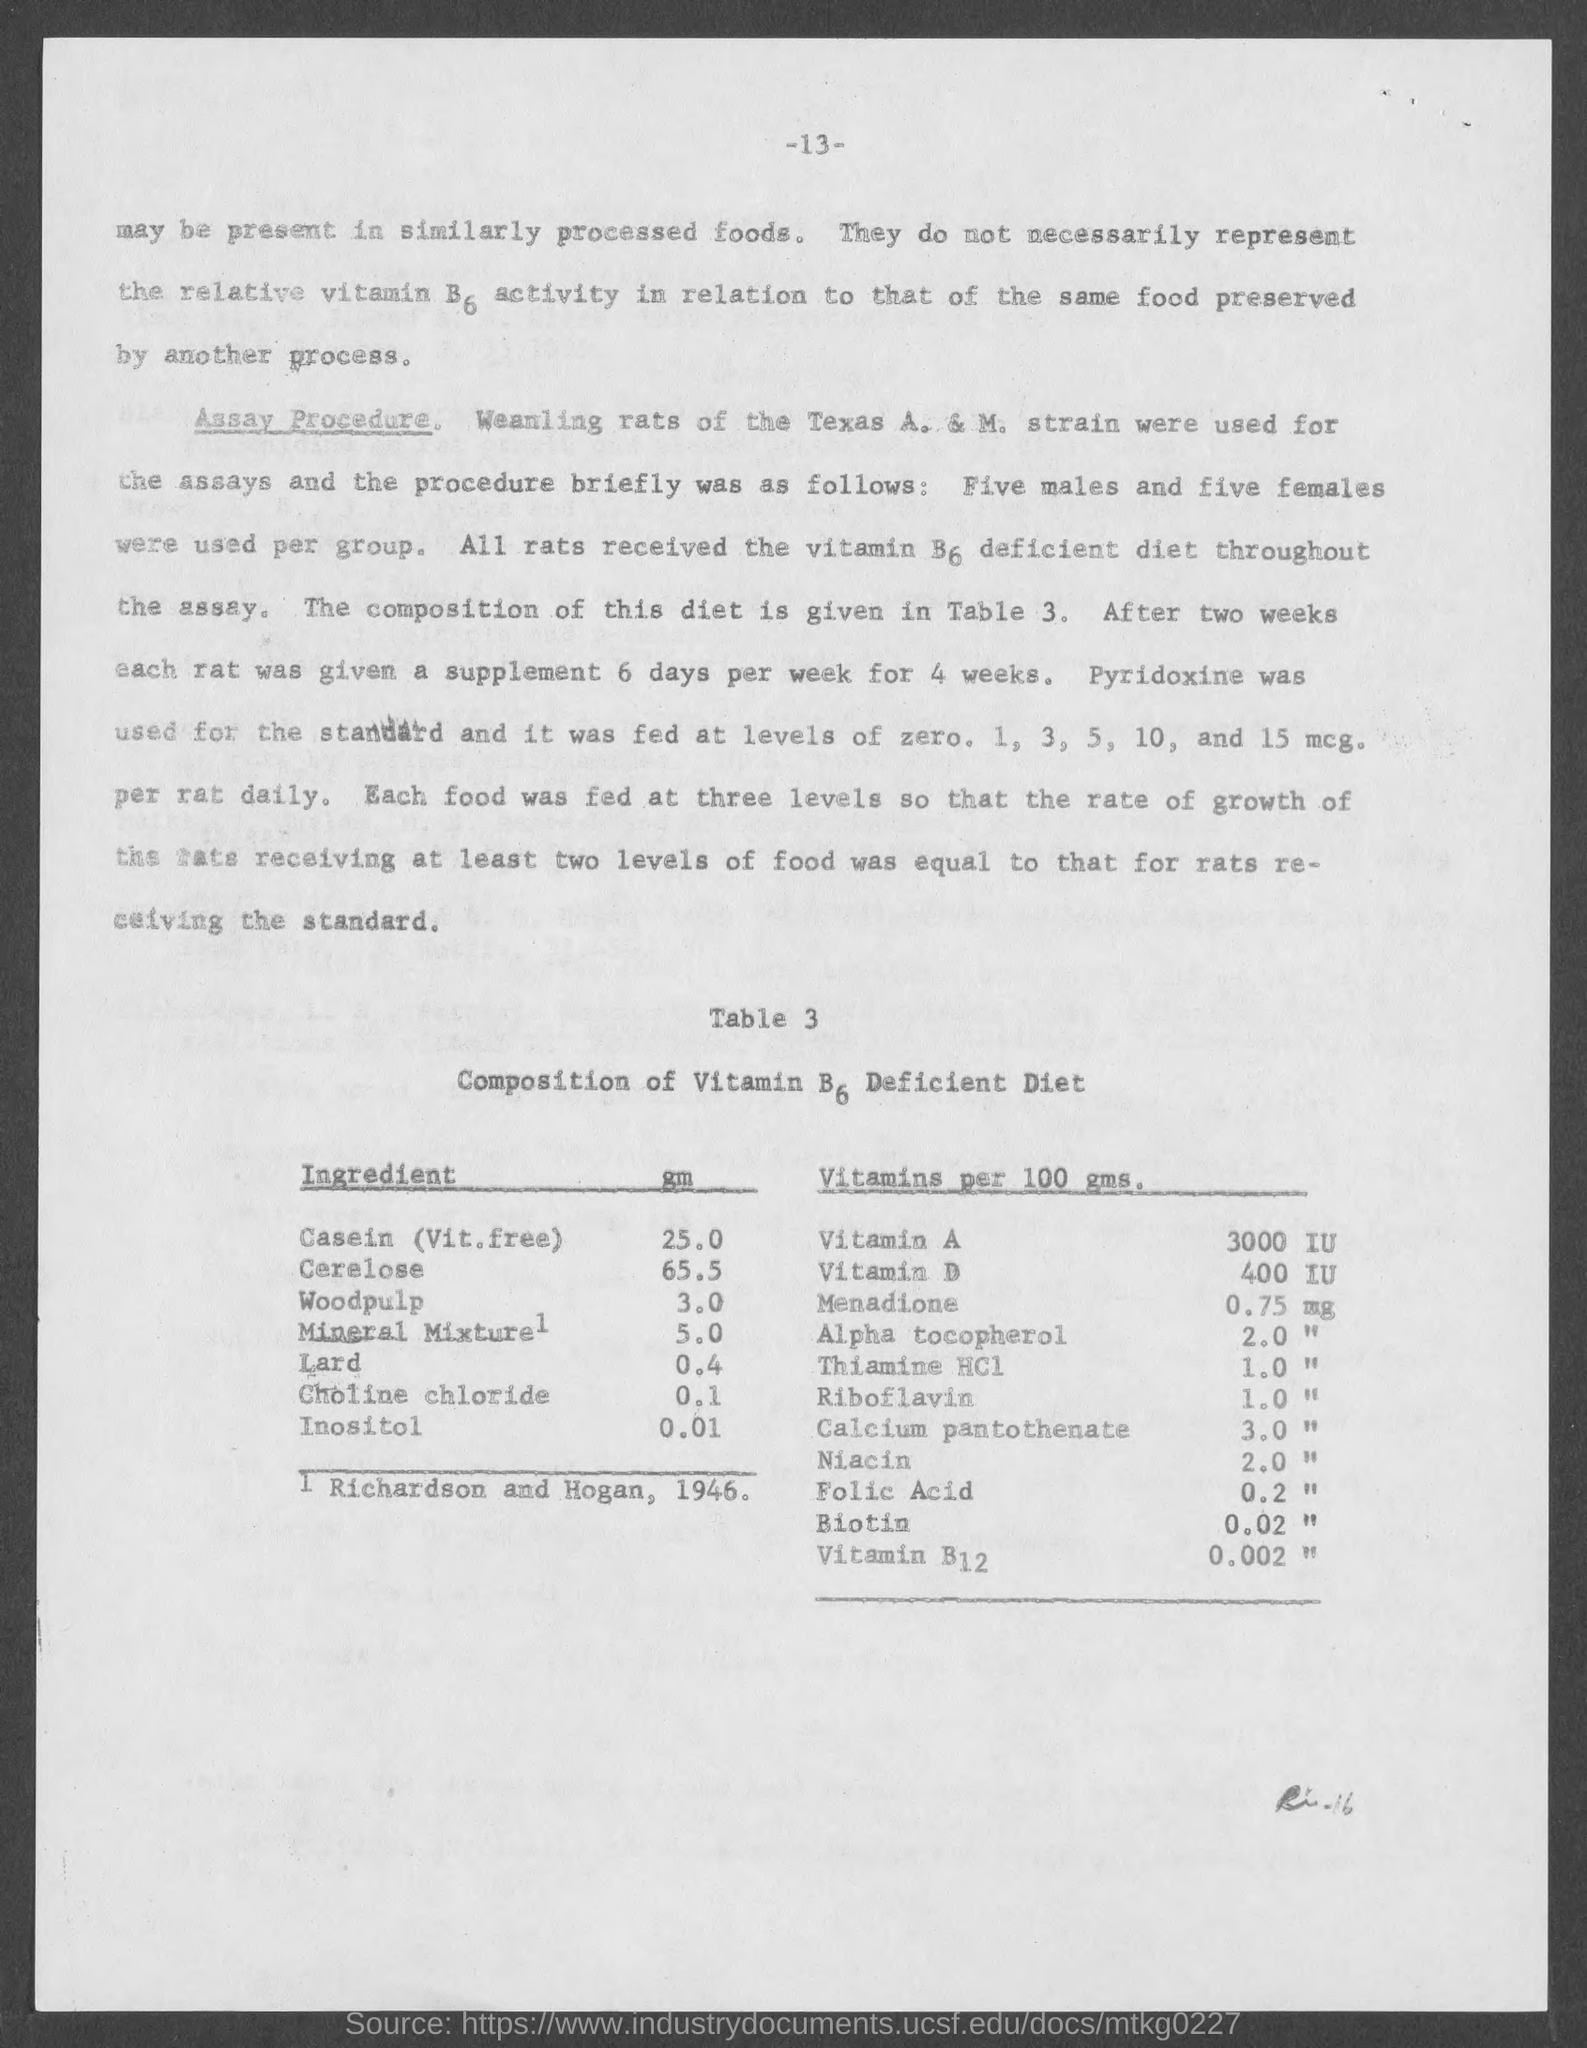How Much B6 in Casein (Vit. free)?
Ensure brevity in your answer.  25.0. How Much B6 in Cerelose?
Ensure brevity in your answer.  65.5. How Much B6 in Wood pulp?
Your answer should be very brief. 3.0. How Much B6 in Mineral Mixture?
Your answer should be very brief. 5.0. How Much B6 in Lard?
Provide a short and direct response. 0.4. How Much B6 in Chlorine chloride?
Your response must be concise. 0.1. How Much B6 in Inositol?
Your answer should be compact. 0.01. How much Vitamin A per 100 gms.?
Keep it short and to the point. 3000 IU. How much Vitamin D per 100 gms.?
Make the answer very short. 400 IU. 